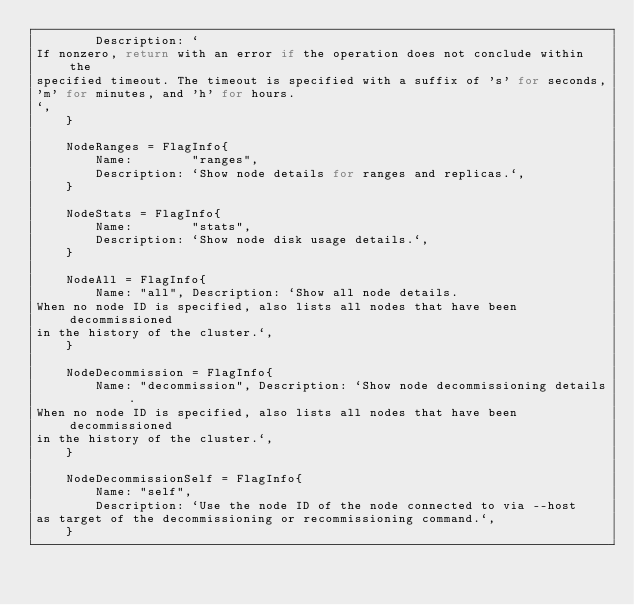<code> <loc_0><loc_0><loc_500><loc_500><_Go_>		Description: `
If nonzero, return with an error if the operation does not conclude within the
specified timeout. The timeout is specified with a suffix of 's' for seconds,
'm' for minutes, and 'h' for hours.
`,
	}

	NodeRanges = FlagInfo{
		Name:        "ranges",
		Description: `Show node details for ranges and replicas.`,
	}

	NodeStats = FlagInfo{
		Name:        "stats",
		Description: `Show node disk usage details.`,
	}

	NodeAll = FlagInfo{
		Name: "all", Description: `Show all node details.
When no node ID is specified, also lists all nodes that have been decommissioned
in the history of the cluster.`,
	}

	NodeDecommission = FlagInfo{
		Name: "decommission", Description: `Show node decommissioning details.
When no node ID is specified, also lists all nodes that have been decommissioned
in the history of the cluster.`,
	}

	NodeDecommissionSelf = FlagInfo{
		Name: "self",
		Description: `Use the node ID of the node connected to via --host
as target of the decommissioning or recommissioning command.`,
	}
</code> 